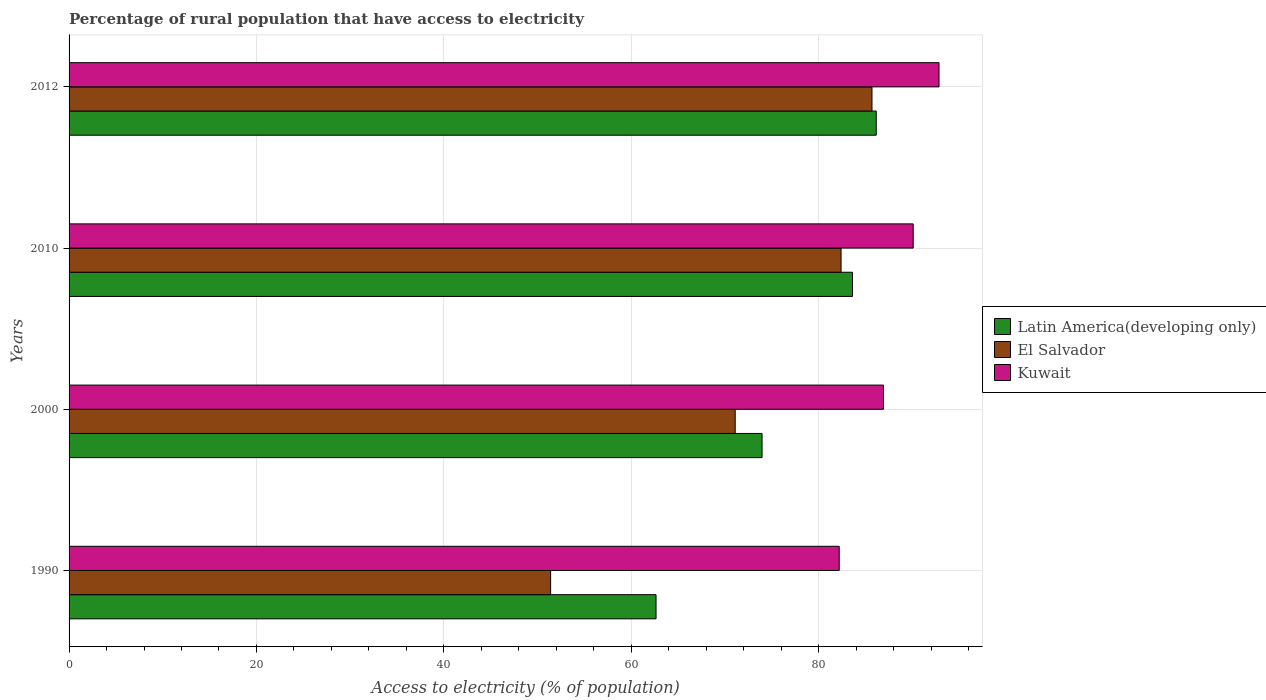Are the number of bars on each tick of the Y-axis equal?
Ensure brevity in your answer.  Yes. How many bars are there on the 4th tick from the top?
Provide a succinct answer. 3. How many bars are there on the 2nd tick from the bottom?
Offer a very short reply. 3. In how many cases, is the number of bars for a given year not equal to the number of legend labels?
Provide a short and direct response. 0. What is the percentage of rural population that have access to electricity in Latin America(developing only) in 2010?
Offer a very short reply. 83.62. Across all years, what is the maximum percentage of rural population that have access to electricity in Latin America(developing only)?
Make the answer very short. 86.15. Across all years, what is the minimum percentage of rural population that have access to electricity in Kuwait?
Your answer should be compact. 82.2. What is the total percentage of rural population that have access to electricity in Kuwait in the graph?
Provide a short and direct response. 352.08. What is the difference between the percentage of rural population that have access to electricity in Latin America(developing only) in 1990 and that in 2012?
Provide a short and direct response. -23.5. What is the difference between the percentage of rural population that have access to electricity in El Salvador in 1990 and the percentage of rural population that have access to electricity in Latin America(developing only) in 2012?
Your answer should be compact. -34.75. What is the average percentage of rural population that have access to electricity in Kuwait per year?
Make the answer very short. 88.02. In the year 2000, what is the difference between the percentage of rural population that have access to electricity in El Salvador and percentage of rural population that have access to electricity in Kuwait?
Your answer should be very brief. -15.83. What is the ratio of the percentage of rural population that have access to electricity in Kuwait in 2010 to that in 2012?
Ensure brevity in your answer.  0.97. Is the percentage of rural population that have access to electricity in El Salvador in 2010 less than that in 2012?
Your answer should be compact. Yes. Is the difference between the percentage of rural population that have access to electricity in El Salvador in 1990 and 2010 greater than the difference between the percentage of rural population that have access to electricity in Kuwait in 1990 and 2010?
Your answer should be compact. No. What is the difference between the highest and the second highest percentage of rural population that have access to electricity in Latin America(developing only)?
Offer a terse response. 2.53. What is the difference between the highest and the lowest percentage of rural population that have access to electricity in Latin America(developing only)?
Provide a short and direct response. 23.5. In how many years, is the percentage of rural population that have access to electricity in El Salvador greater than the average percentage of rural population that have access to electricity in El Salvador taken over all years?
Provide a short and direct response. 2. What does the 1st bar from the top in 2012 represents?
Provide a succinct answer. Kuwait. What does the 3rd bar from the bottom in 2010 represents?
Provide a short and direct response. Kuwait. How many bars are there?
Your response must be concise. 12. How many years are there in the graph?
Your answer should be compact. 4. How are the legend labels stacked?
Your answer should be very brief. Vertical. What is the title of the graph?
Ensure brevity in your answer.  Percentage of rural population that have access to electricity. What is the label or title of the X-axis?
Offer a very short reply. Access to electricity (% of population). What is the label or title of the Y-axis?
Your response must be concise. Years. What is the Access to electricity (% of population) in Latin America(developing only) in 1990?
Your response must be concise. 62.65. What is the Access to electricity (% of population) in El Salvador in 1990?
Offer a very short reply. 51.4. What is the Access to electricity (% of population) of Kuwait in 1990?
Provide a succinct answer. 82.2. What is the Access to electricity (% of population) in Latin America(developing only) in 2000?
Your answer should be compact. 73.97. What is the Access to electricity (% of population) of El Salvador in 2000?
Your answer should be very brief. 71.1. What is the Access to electricity (% of population) of Kuwait in 2000?
Offer a terse response. 86.93. What is the Access to electricity (% of population) of Latin America(developing only) in 2010?
Offer a very short reply. 83.62. What is the Access to electricity (% of population) in El Salvador in 2010?
Offer a terse response. 82.4. What is the Access to electricity (% of population) of Kuwait in 2010?
Your answer should be compact. 90.1. What is the Access to electricity (% of population) in Latin America(developing only) in 2012?
Make the answer very short. 86.15. What is the Access to electricity (% of population) of El Salvador in 2012?
Offer a very short reply. 85.7. What is the Access to electricity (% of population) in Kuwait in 2012?
Offer a terse response. 92.85. Across all years, what is the maximum Access to electricity (% of population) of Latin America(developing only)?
Offer a terse response. 86.15. Across all years, what is the maximum Access to electricity (% of population) of El Salvador?
Your answer should be very brief. 85.7. Across all years, what is the maximum Access to electricity (% of population) of Kuwait?
Provide a succinct answer. 92.85. Across all years, what is the minimum Access to electricity (% of population) in Latin America(developing only)?
Provide a short and direct response. 62.65. Across all years, what is the minimum Access to electricity (% of population) in El Salvador?
Provide a succinct answer. 51.4. Across all years, what is the minimum Access to electricity (% of population) of Kuwait?
Your response must be concise. 82.2. What is the total Access to electricity (% of population) in Latin America(developing only) in the graph?
Your answer should be compact. 306.39. What is the total Access to electricity (% of population) of El Salvador in the graph?
Provide a succinct answer. 290.6. What is the total Access to electricity (% of population) of Kuwait in the graph?
Offer a very short reply. 352.08. What is the difference between the Access to electricity (% of population) in Latin America(developing only) in 1990 and that in 2000?
Provide a succinct answer. -11.32. What is the difference between the Access to electricity (% of population) in El Salvador in 1990 and that in 2000?
Your answer should be compact. -19.7. What is the difference between the Access to electricity (% of population) of Kuwait in 1990 and that in 2000?
Your answer should be compact. -4.72. What is the difference between the Access to electricity (% of population) in Latin America(developing only) in 1990 and that in 2010?
Your answer should be very brief. -20.97. What is the difference between the Access to electricity (% of population) of El Salvador in 1990 and that in 2010?
Your answer should be compact. -31. What is the difference between the Access to electricity (% of population) of Kuwait in 1990 and that in 2010?
Provide a succinct answer. -7.9. What is the difference between the Access to electricity (% of population) in Latin America(developing only) in 1990 and that in 2012?
Your response must be concise. -23.5. What is the difference between the Access to electricity (% of population) of El Salvador in 1990 and that in 2012?
Provide a succinct answer. -34.3. What is the difference between the Access to electricity (% of population) in Kuwait in 1990 and that in 2012?
Keep it short and to the point. -10.65. What is the difference between the Access to electricity (% of population) of Latin America(developing only) in 2000 and that in 2010?
Offer a very short reply. -9.65. What is the difference between the Access to electricity (% of population) in El Salvador in 2000 and that in 2010?
Make the answer very short. -11.3. What is the difference between the Access to electricity (% of population) in Kuwait in 2000 and that in 2010?
Your response must be concise. -3.17. What is the difference between the Access to electricity (% of population) in Latin America(developing only) in 2000 and that in 2012?
Offer a very short reply. -12.19. What is the difference between the Access to electricity (% of population) of El Salvador in 2000 and that in 2012?
Keep it short and to the point. -14.6. What is the difference between the Access to electricity (% of population) in Kuwait in 2000 and that in 2012?
Your response must be concise. -5.93. What is the difference between the Access to electricity (% of population) of Latin America(developing only) in 2010 and that in 2012?
Offer a terse response. -2.53. What is the difference between the Access to electricity (% of population) of Kuwait in 2010 and that in 2012?
Ensure brevity in your answer.  -2.75. What is the difference between the Access to electricity (% of population) of Latin America(developing only) in 1990 and the Access to electricity (% of population) of El Salvador in 2000?
Offer a very short reply. -8.45. What is the difference between the Access to electricity (% of population) in Latin America(developing only) in 1990 and the Access to electricity (% of population) in Kuwait in 2000?
Provide a short and direct response. -24.27. What is the difference between the Access to electricity (% of population) of El Salvador in 1990 and the Access to electricity (% of population) of Kuwait in 2000?
Offer a very short reply. -35.53. What is the difference between the Access to electricity (% of population) in Latin America(developing only) in 1990 and the Access to electricity (% of population) in El Salvador in 2010?
Provide a succinct answer. -19.75. What is the difference between the Access to electricity (% of population) in Latin America(developing only) in 1990 and the Access to electricity (% of population) in Kuwait in 2010?
Make the answer very short. -27.45. What is the difference between the Access to electricity (% of population) in El Salvador in 1990 and the Access to electricity (% of population) in Kuwait in 2010?
Provide a short and direct response. -38.7. What is the difference between the Access to electricity (% of population) of Latin America(developing only) in 1990 and the Access to electricity (% of population) of El Salvador in 2012?
Your answer should be compact. -23.05. What is the difference between the Access to electricity (% of population) of Latin America(developing only) in 1990 and the Access to electricity (% of population) of Kuwait in 2012?
Offer a very short reply. -30.2. What is the difference between the Access to electricity (% of population) of El Salvador in 1990 and the Access to electricity (% of population) of Kuwait in 2012?
Keep it short and to the point. -41.45. What is the difference between the Access to electricity (% of population) of Latin America(developing only) in 2000 and the Access to electricity (% of population) of El Salvador in 2010?
Your answer should be very brief. -8.43. What is the difference between the Access to electricity (% of population) in Latin America(developing only) in 2000 and the Access to electricity (% of population) in Kuwait in 2010?
Offer a very short reply. -16.13. What is the difference between the Access to electricity (% of population) in El Salvador in 2000 and the Access to electricity (% of population) in Kuwait in 2010?
Your answer should be compact. -19. What is the difference between the Access to electricity (% of population) of Latin America(developing only) in 2000 and the Access to electricity (% of population) of El Salvador in 2012?
Offer a terse response. -11.73. What is the difference between the Access to electricity (% of population) of Latin America(developing only) in 2000 and the Access to electricity (% of population) of Kuwait in 2012?
Offer a terse response. -18.89. What is the difference between the Access to electricity (% of population) of El Salvador in 2000 and the Access to electricity (% of population) of Kuwait in 2012?
Your response must be concise. -21.75. What is the difference between the Access to electricity (% of population) of Latin America(developing only) in 2010 and the Access to electricity (% of population) of El Salvador in 2012?
Provide a short and direct response. -2.08. What is the difference between the Access to electricity (% of population) of Latin America(developing only) in 2010 and the Access to electricity (% of population) of Kuwait in 2012?
Keep it short and to the point. -9.24. What is the difference between the Access to electricity (% of population) in El Salvador in 2010 and the Access to electricity (% of population) in Kuwait in 2012?
Your response must be concise. -10.45. What is the average Access to electricity (% of population) of Latin America(developing only) per year?
Offer a terse response. 76.6. What is the average Access to electricity (% of population) in El Salvador per year?
Your answer should be very brief. 72.65. What is the average Access to electricity (% of population) in Kuwait per year?
Provide a short and direct response. 88.02. In the year 1990, what is the difference between the Access to electricity (% of population) in Latin America(developing only) and Access to electricity (% of population) in El Salvador?
Your response must be concise. 11.25. In the year 1990, what is the difference between the Access to electricity (% of population) in Latin America(developing only) and Access to electricity (% of population) in Kuwait?
Provide a short and direct response. -19.55. In the year 1990, what is the difference between the Access to electricity (% of population) in El Salvador and Access to electricity (% of population) in Kuwait?
Provide a short and direct response. -30.8. In the year 2000, what is the difference between the Access to electricity (% of population) in Latin America(developing only) and Access to electricity (% of population) in El Salvador?
Keep it short and to the point. 2.87. In the year 2000, what is the difference between the Access to electricity (% of population) in Latin America(developing only) and Access to electricity (% of population) in Kuwait?
Give a very brief answer. -12.96. In the year 2000, what is the difference between the Access to electricity (% of population) in El Salvador and Access to electricity (% of population) in Kuwait?
Your answer should be compact. -15.83. In the year 2010, what is the difference between the Access to electricity (% of population) of Latin America(developing only) and Access to electricity (% of population) of El Salvador?
Make the answer very short. 1.22. In the year 2010, what is the difference between the Access to electricity (% of population) of Latin America(developing only) and Access to electricity (% of population) of Kuwait?
Ensure brevity in your answer.  -6.48. In the year 2010, what is the difference between the Access to electricity (% of population) in El Salvador and Access to electricity (% of population) in Kuwait?
Your answer should be very brief. -7.7. In the year 2012, what is the difference between the Access to electricity (% of population) in Latin America(developing only) and Access to electricity (% of population) in El Salvador?
Your answer should be very brief. 0.45. In the year 2012, what is the difference between the Access to electricity (% of population) in Latin America(developing only) and Access to electricity (% of population) in Kuwait?
Give a very brief answer. -6.7. In the year 2012, what is the difference between the Access to electricity (% of population) of El Salvador and Access to electricity (% of population) of Kuwait?
Your answer should be compact. -7.15. What is the ratio of the Access to electricity (% of population) of Latin America(developing only) in 1990 to that in 2000?
Your answer should be compact. 0.85. What is the ratio of the Access to electricity (% of population) in El Salvador in 1990 to that in 2000?
Give a very brief answer. 0.72. What is the ratio of the Access to electricity (% of population) of Kuwait in 1990 to that in 2000?
Provide a short and direct response. 0.95. What is the ratio of the Access to electricity (% of population) of Latin America(developing only) in 1990 to that in 2010?
Your answer should be compact. 0.75. What is the ratio of the Access to electricity (% of population) of El Salvador in 1990 to that in 2010?
Give a very brief answer. 0.62. What is the ratio of the Access to electricity (% of population) of Kuwait in 1990 to that in 2010?
Offer a terse response. 0.91. What is the ratio of the Access to electricity (% of population) of Latin America(developing only) in 1990 to that in 2012?
Give a very brief answer. 0.73. What is the ratio of the Access to electricity (% of population) in El Salvador in 1990 to that in 2012?
Your answer should be compact. 0.6. What is the ratio of the Access to electricity (% of population) of Kuwait in 1990 to that in 2012?
Ensure brevity in your answer.  0.89. What is the ratio of the Access to electricity (% of population) in Latin America(developing only) in 2000 to that in 2010?
Your answer should be very brief. 0.88. What is the ratio of the Access to electricity (% of population) of El Salvador in 2000 to that in 2010?
Ensure brevity in your answer.  0.86. What is the ratio of the Access to electricity (% of population) in Kuwait in 2000 to that in 2010?
Your answer should be very brief. 0.96. What is the ratio of the Access to electricity (% of population) in Latin America(developing only) in 2000 to that in 2012?
Your answer should be very brief. 0.86. What is the ratio of the Access to electricity (% of population) of El Salvador in 2000 to that in 2012?
Give a very brief answer. 0.83. What is the ratio of the Access to electricity (% of population) of Kuwait in 2000 to that in 2012?
Offer a very short reply. 0.94. What is the ratio of the Access to electricity (% of population) in Latin America(developing only) in 2010 to that in 2012?
Give a very brief answer. 0.97. What is the ratio of the Access to electricity (% of population) in El Salvador in 2010 to that in 2012?
Your answer should be very brief. 0.96. What is the ratio of the Access to electricity (% of population) of Kuwait in 2010 to that in 2012?
Your response must be concise. 0.97. What is the difference between the highest and the second highest Access to electricity (% of population) of Latin America(developing only)?
Offer a terse response. 2.53. What is the difference between the highest and the second highest Access to electricity (% of population) of El Salvador?
Your answer should be compact. 3.3. What is the difference between the highest and the second highest Access to electricity (% of population) of Kuwait?
Provide a succinct answer. 2.75. What is the difference between the highest and the lowest Access to electricity (% of population) in Latin America(developing only)?
Keep it short and to the point. 23.5. What is the difference between the highest and the lowest Access to electricity (% of population) in El Salvador?
Your answer should be compact. 34.3. What is the difference between the highest and the lowest Access to electricity (% of population) of Kuwait?
Give a very brief answer. 10.65. 